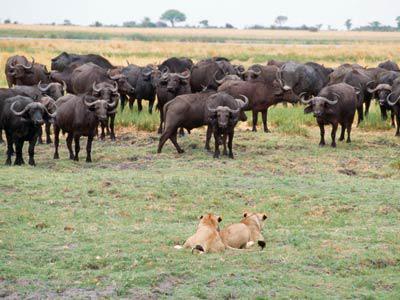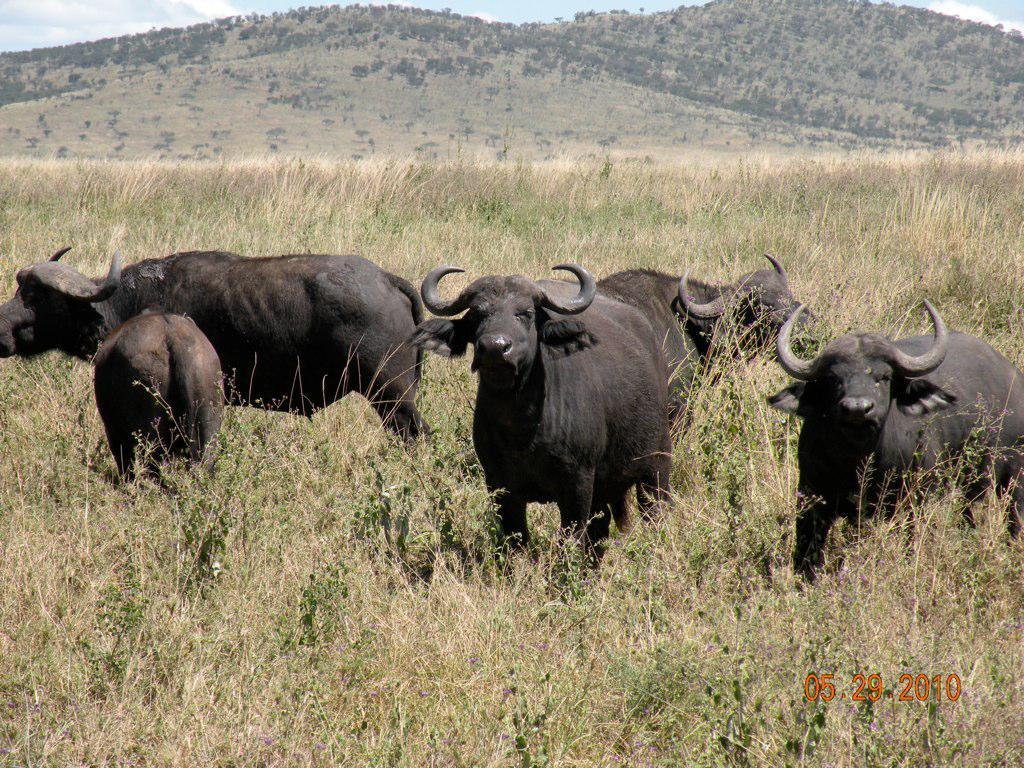The first image is the image on the left, the second image is the image on the right. For the images displayed, is the sentence "A water buffalo is being used to pull a person." factually correct? Answer yes or no. No. The first image is the image on the left, the second image is the image on the right. Assess this claim about the two images: "At least one person is behind a hitched team of two water buffalo in one image.". Correct or not? Answer yes or no. No. 